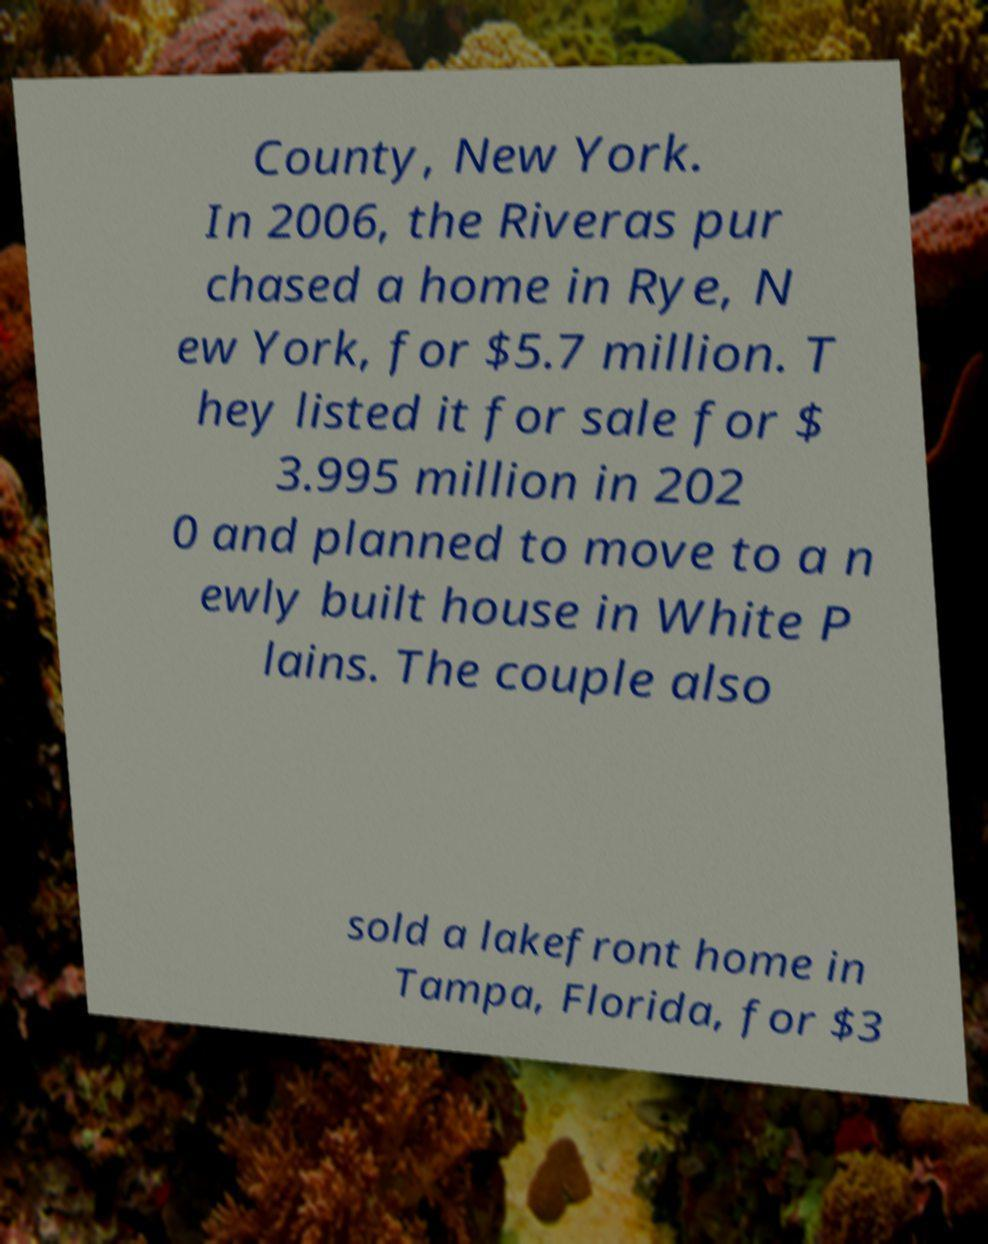Could you assist in decoding the text presented in this image and type it out clearly? County, New York. In 2006, the Riveras pur chased a home in Rye, N ew York, for $5.7 million. T hey listed it for sale for $ 3.995 million in 202 0 and planned to move to a n ewly built house in White P lains. The couple also sold a lakefront home in Tampa, Florida, for $3 